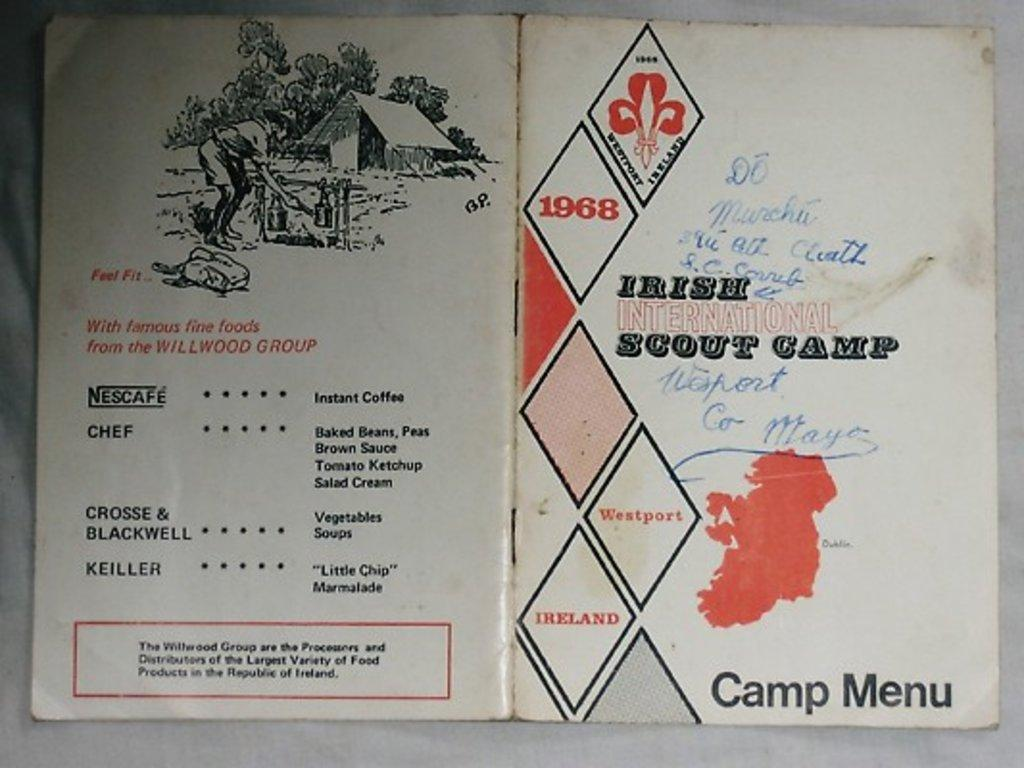<image>
Summarize the visual content of the image. The document shown is a menu from 1968 for Scout camp. 